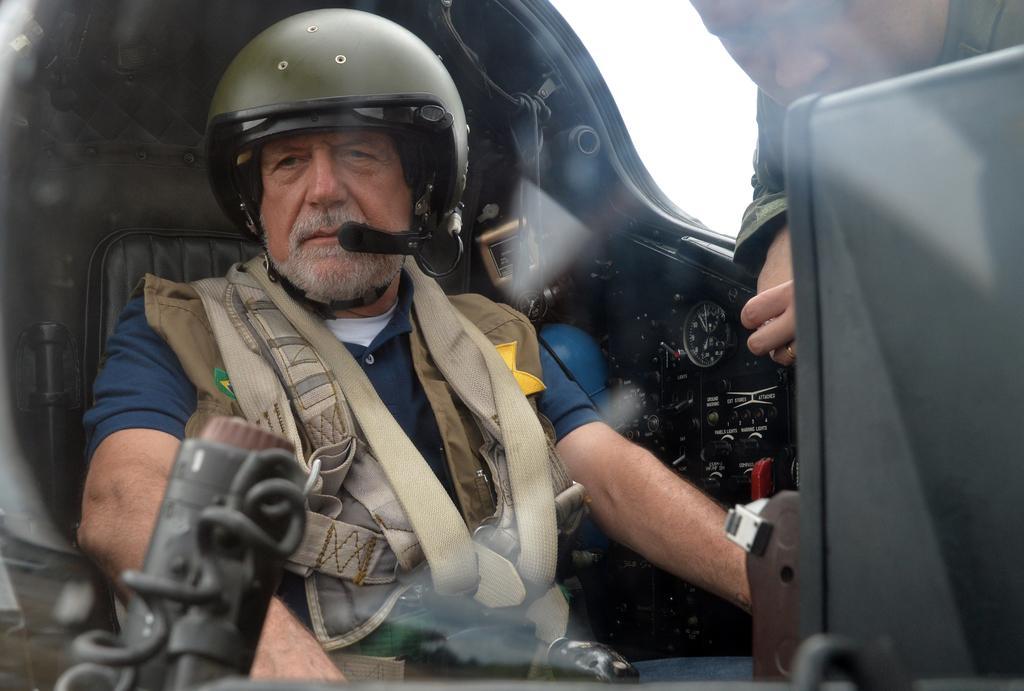How would you summarize this image in a sentence or two? In the picture I can see a person wearing jacket and helmet is sitting inside an airplane and here we can see another person on the right side of the image. 